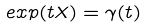Convert formula to latex. <formula><loc_0><loc_0><loc_500><loc_500>e x p ( t X ) = \gamma ( t )</formula> 